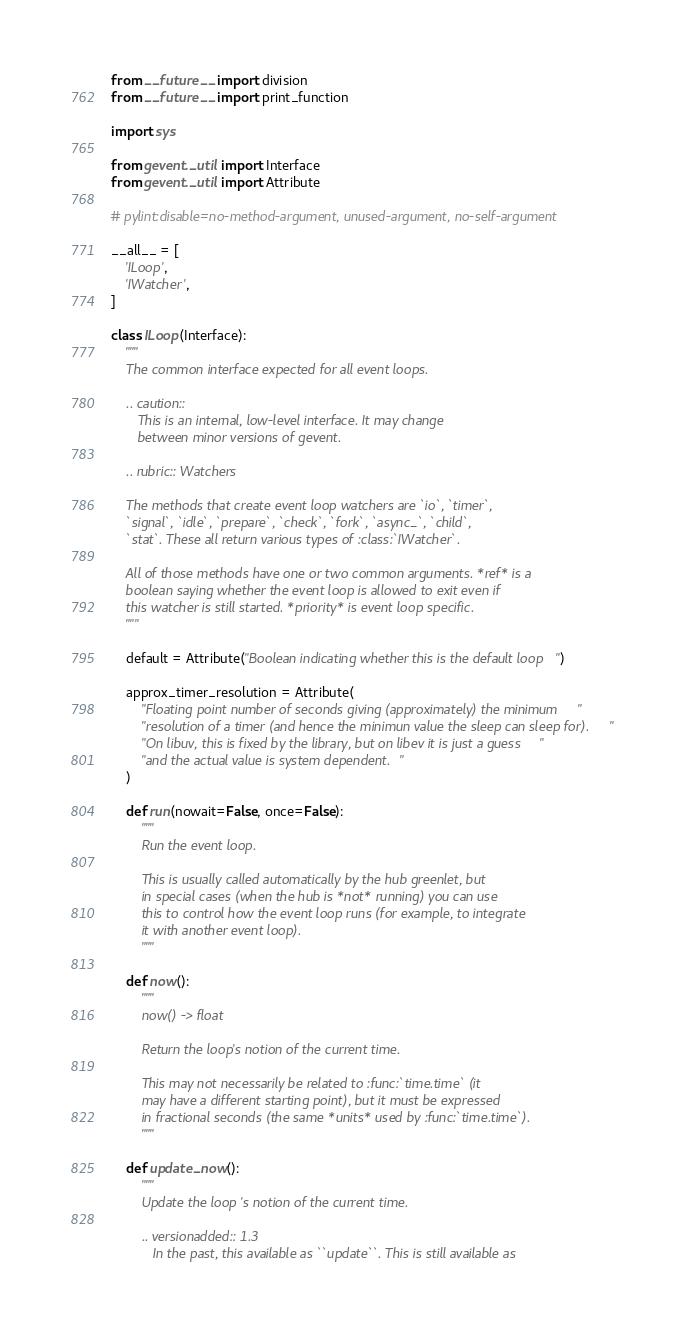<code> <loc_0><loc_0><loc_500><loc_500><_Python_>from __future__ import division
from __future__ import print_function

import sys

from gevent._util import Interface
from gevent._util import Attribute

# pylint:disable=no-method-argument, unused-argument, no-self-argument

__all__ = [
    'ILoop',
    'IWatcher',
]

class ILoop(Interface):
    """
    The common interface expected for all event loops.

    .. caution::
       This is an internal, low-level interface. It may change
       between minor versions of gevent.

    .. rubric:: Watchers

    The methods that create event loop watchers are `io`, `timer`,
    `signal`, `idle`, `prepare`, `check`, `fork`, `async_`, `child`,
    `stat`. These all return various types of :class:`IWatcher`.

    All of those methods have one or two common arguments. *ref* is a
    boolean saying whether the event loop is allowed to exit even if
    this watcher is still started. *priority* is event loop specific.
    """

    default = Attribute("Boolean indicating whether this is the default loop")

    approx_timer_resolution = Attribute(
        "Floating point number of seconds giving (approximately) the minimum "
        "resolution of a timer (and hence the minimun value the sleep can sleep for). "
        "On libuv, this is fixed by the library, but on libev it is just a guess "
        "and the actual value is system dependent."
    )

    def run(nowait=False, once=False):
        """
        Run the event loop.

        This is usually called automatically by the hub greenlet, but
        in special cases (when the hub is *not* running) you can use
        this to control how the event loop runs (for example, to integrate
        it with another event loop).
        """

    def now():
        """
        now() -> float

        Return the loop's notion of the current time.

        This may not necessarily be related to :func:`time.time` (it
        may have a different starting point), but it must be expressed
        in fractional seconds (the same *units* used by :func:`time.time`).
        """

    def update_now():
        """
        Update the loop's notion of the current time.

        .. versionadded:: 1.3
           In the past, this available as ``update``. This is still available as</code> 